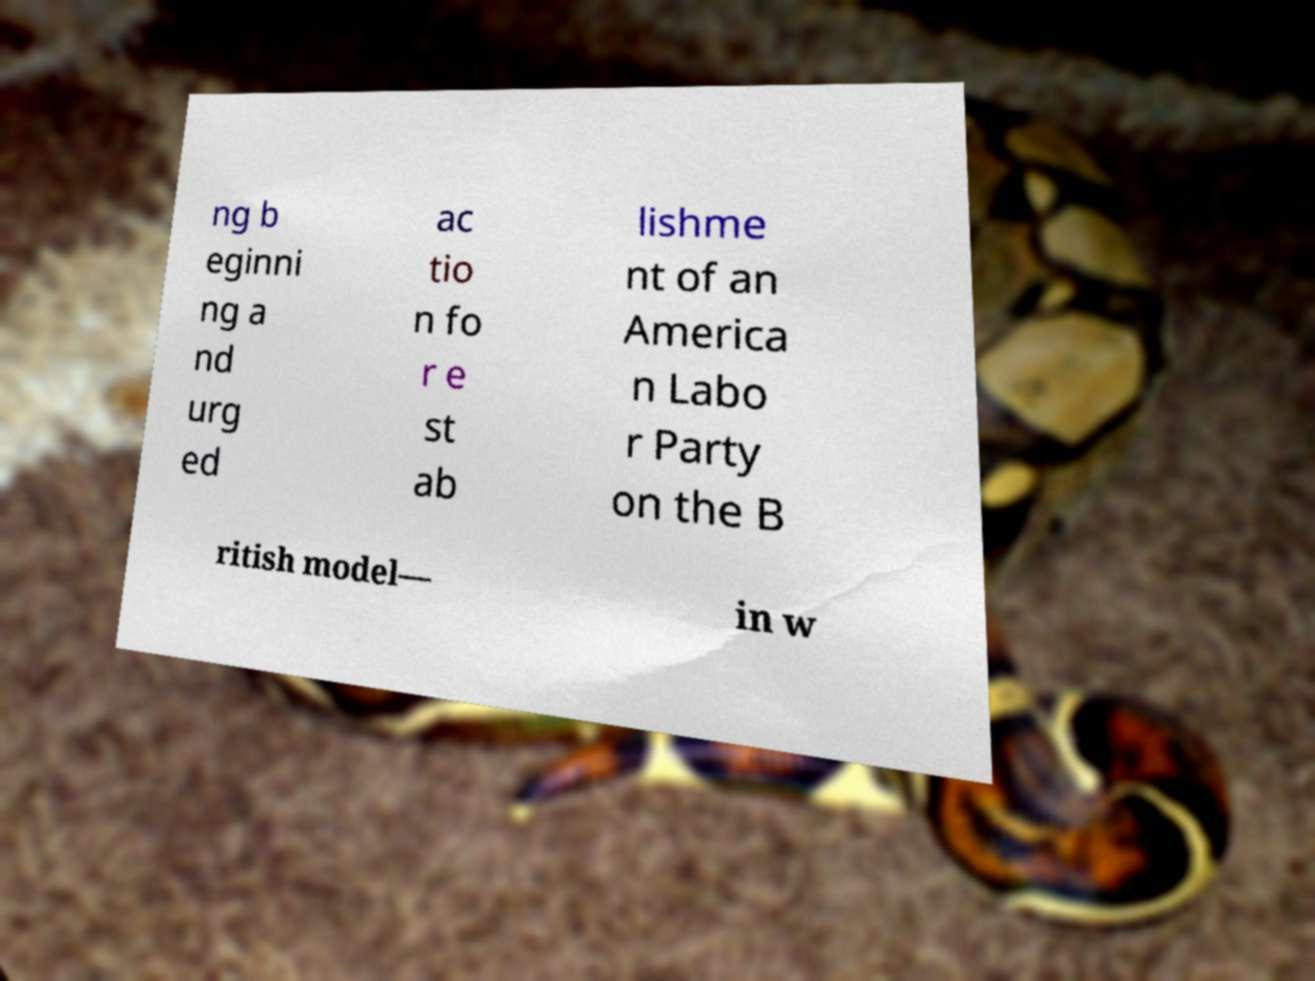Can you accurately transcribe the text from the provided image for me? ng b eginni ng a nd urg ed ac tio n fo r e st ab lishme nt of an America n Labo r Party on the B ritish model— in w 